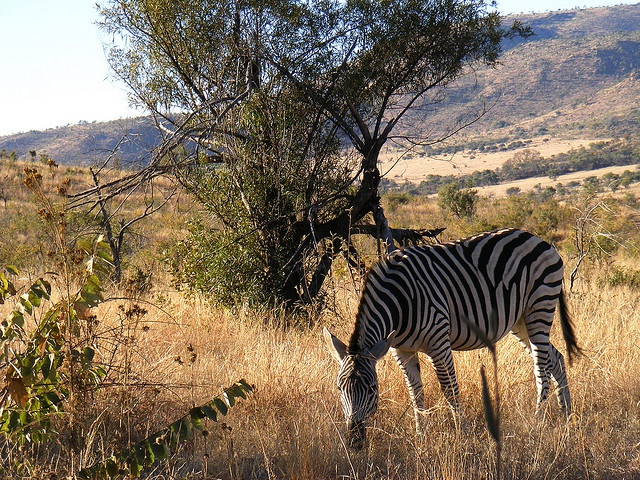Describe the objects in this image and their specific colors. I can see a zebra in white, black, gray, and maroon tones in this image. 